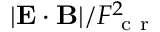Convert formula to latex. <formula><loc_0><loc_0><loc_500><loc_500>| E \cdot B | / F _ { c r } ^ { 2 }</formula> 